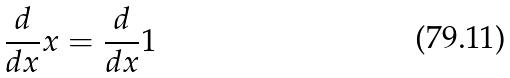Convert formula to latex. <formula><loc_0><loc_0><loc_500><loc_500>\frac { d } { d x } x = \frac { d } { d x } 1</formula> 